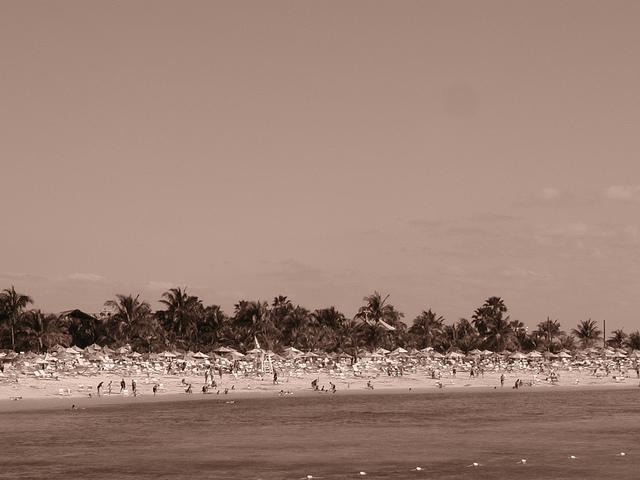How many cars on the locomotive have unprotected wheels?
Give a very brief answer. 0. 